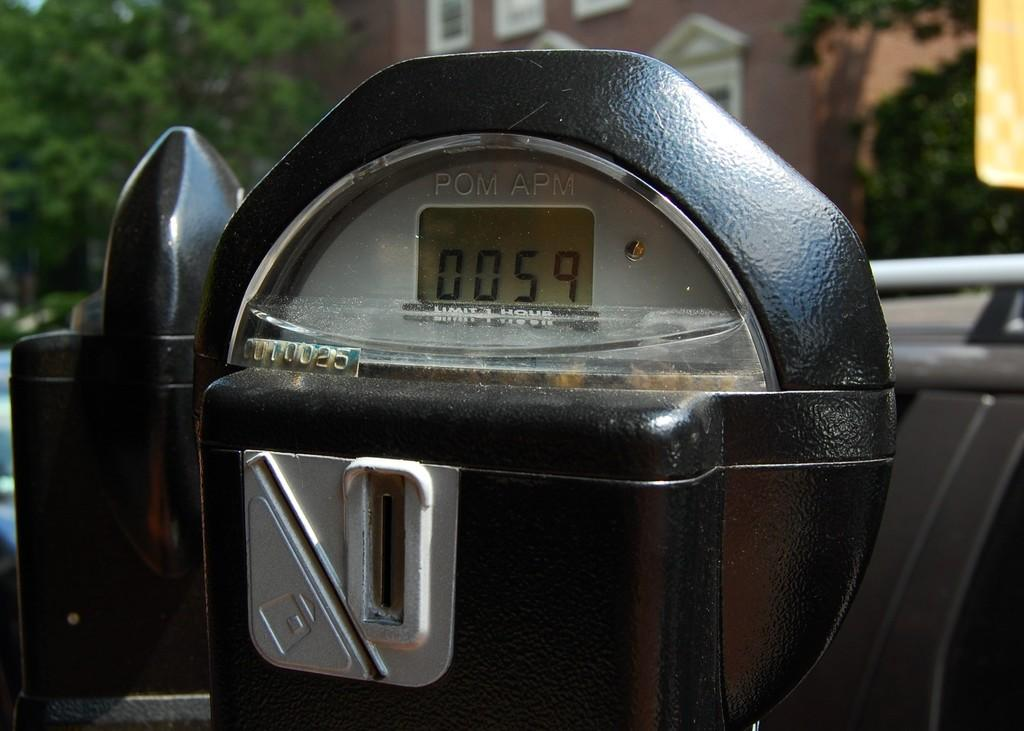<image>
Offer a succinct explanation of the picture presented. A digital parking meter with a screen that reads 0059. 